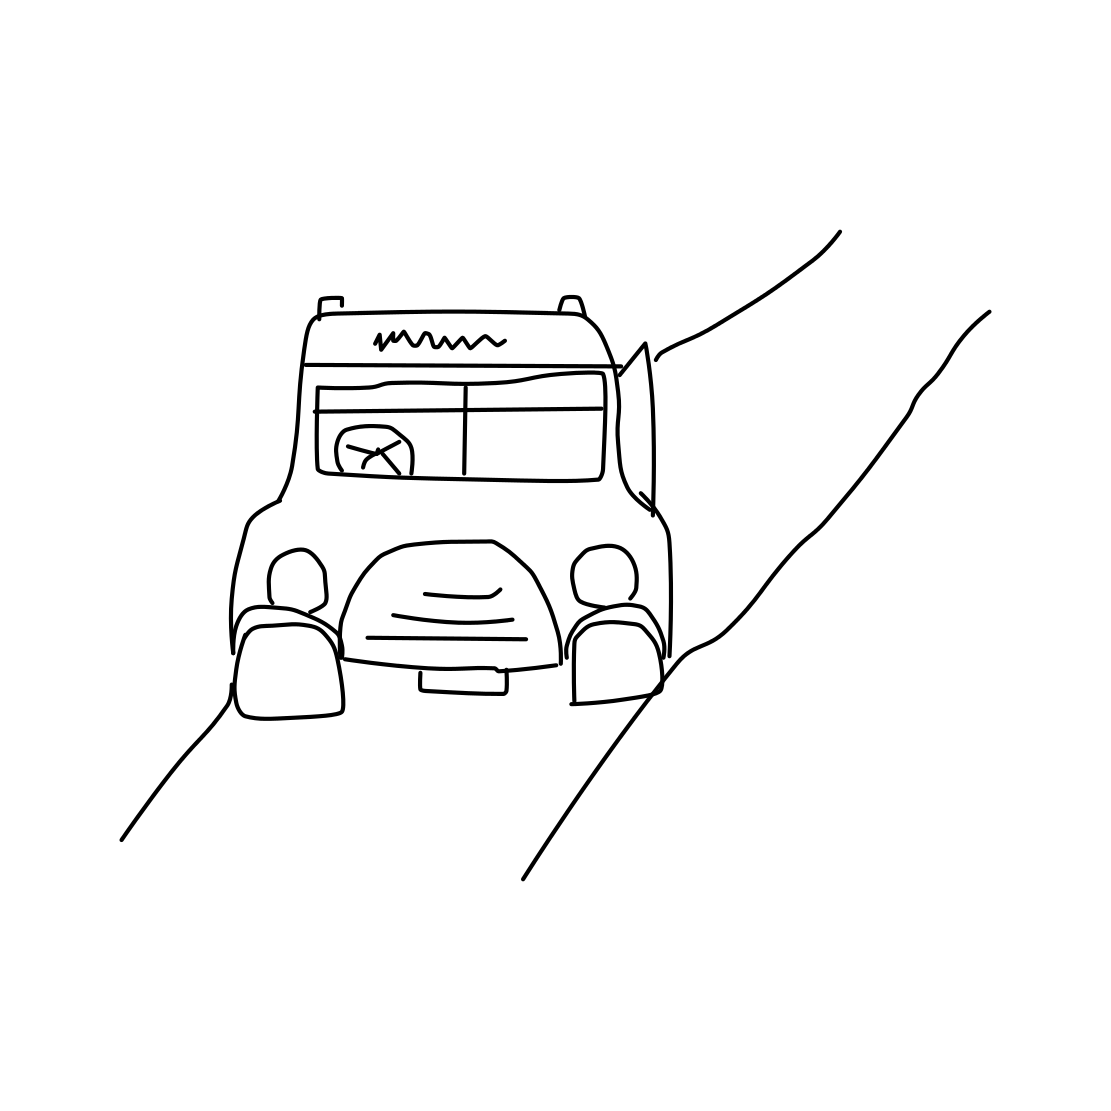Is this a truck in the image? Based on the image provided, the vehicle appears to be a simple line drawing of a classic style truck, featuring prominent characteristics such as a sizable cabin and an adequately scaled bed behind, typical of what one might imagine when thinking of a truck. 